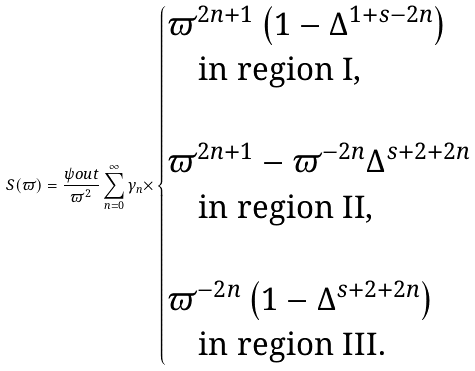Convert formula to latex. <formula><loc_0><loc_0><loc_500><loc_500>S ( \varpi ) = \frac { \psi o u t } { \varpi ^ { 2 } } \sum _ { n = 0 } ^ { \infty } { \gamma _ { n } \times } \begin{cases} \varpi ^ { 2 n + 1 } \left ( 1 - \Delta ^ { 1 + s - 2 n } \right ) \\ \quad \text {in region I} , \\ \\ \varpi ^ { 2 n + 1 } - \varpi ^ { - 2 n } \Delta ^ { s + 2 + 2 n } \\ \quad \text {in region II} , \\ \\ \varpi ^ { - 2 n } \left ( 1 - \Delta ^ { s + 2 + 2 n } \right ) \\ \quad \text {in region III.} \end{cases}</formula> 